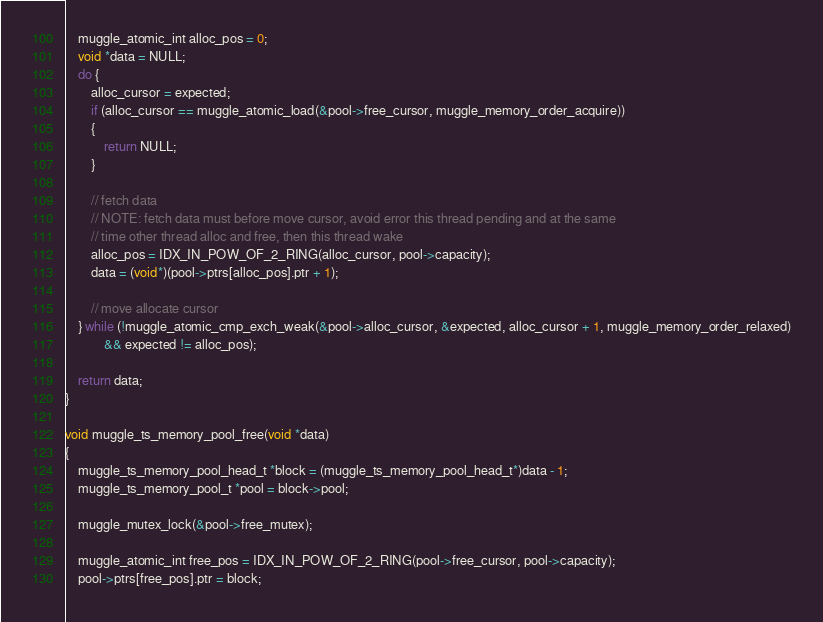<code> <loc_0><loc_0><loc_500><loc_500><_C_>	muggle_atomic_int alloc_pos = 0;
	void *data = NULL;
	do {
		alloc_cursor = expected;
		if (alloc_cursor == muggle_atomic_load(&pool->free_cursor, muggle_memory_order_acquire))
		{
			return NULL;
		}

		// fetch data
		// NOTE: fetch data must before move cursor, avoid error this thread pending and at the same 
		// time other thread alloc and free, then this thread wake
		alloc_pos = IDX_IN_POW_OF_2_RING(alloc_cursor, pool->capacity);
		data = (void*)(pool->ptrs[alloc_pos].ptr + 1);

		// move allocate cursor
	} while (!muggle_atomic_cmp_exch_weak(&pool->alloc_cursor, &expected, alloc_cursor + 1, muggle_memory_order_relaxed)
			&& expected != alloc_pos);

	return data;
}

void muggle_ts_memory_pool_free(void *data)
{
	muggle_ts_memory_pool_head_t *block = (muggle_ts_memory_pool_head_t*)data - 1;
	muggle_ts_memory_pool_t *pool = block->pool;

	muggle_mutex_lock(&pool->free_mutex);

	muggle_atomic_int free_pos = IDX_IN_POW_OF_2_RING(pool->free_cursor, pool->capacity);
	pool->ptrs[free_pos].ptr = block;
</code> 